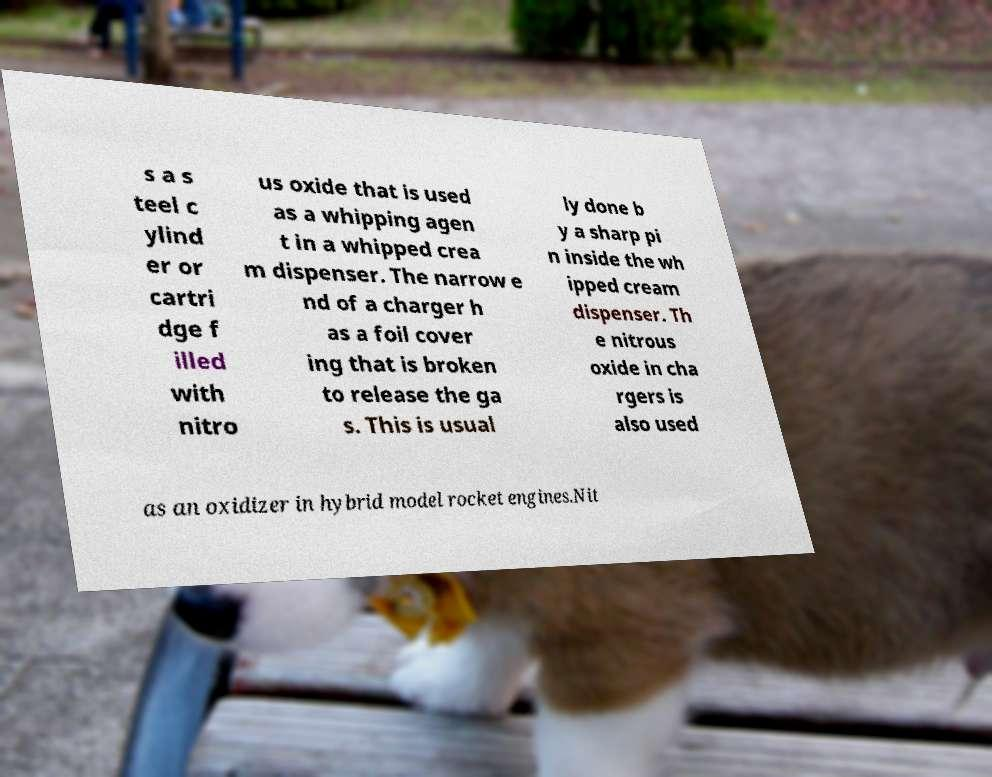There's text embedded in this image that I need extracted. Can you transcribe it verbatim? s a s teel c ylind er or cartri dge f illed with nitro us oxide that is used as a whipping agen t in a whipped crea m dispenser. The narrow e nd of a charger h as a foil cover ing that is broken to release the ga s. This is usual ly done b y a sharp pi n inside the wh ipped cream dispenser. Th e nitrous oxide in cha rgers is also used as an oxidizer in hybrid model rocket engines.Nit 